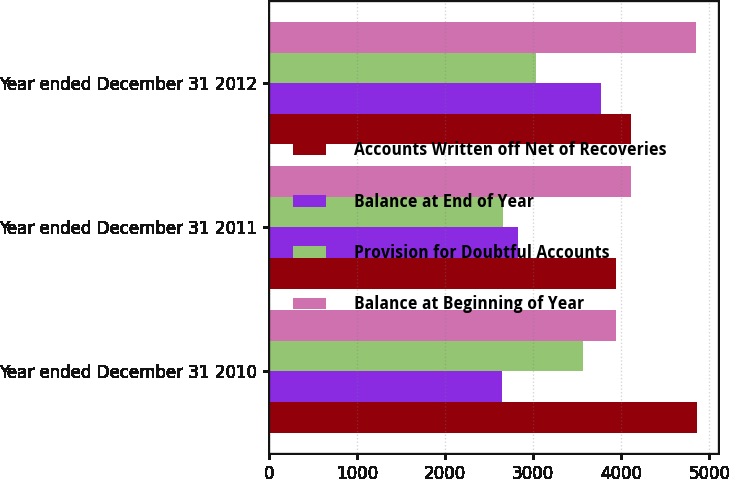Convert chart. <chart><loc_0><loc_0><loc_500><loc_500><stacked_bar_chart><ecel><fcel>Year ended December 31 2010<fcel>Year ended December 31 2011<fcel>Year ended December 31 2012<nl><fcel>Accounts Written off Net of Recoveries<fcel>4860<fcel>3939<fcel>4106<nl><fcel>Balance at End of Year<fcel>2648<fcel>2824<fcel>3770<nl><fcel>Provision for Doubtful Accounts<fcel>3569<fcel>2657<fcel>3030<nl><fcel>Balance at Beginning of Year<fcel>3939<fcel>4106<fcel>4846<nl></chart> 